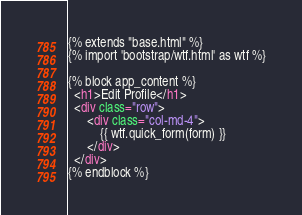<code> <loc_0><loc_0><loc_500><loc_500><_HTML_>{% extends "base.html" %}
{% import 'bootstrap/wtf.html' as wtf %}

{% block app_content %}
  <h1>Edit Profile</h1>
  <div class="row">
      <div class="col-md-4">
          {{ wtf.quick_form(form) }}
      </div>
  </div>
{% endblock %}
</code> 